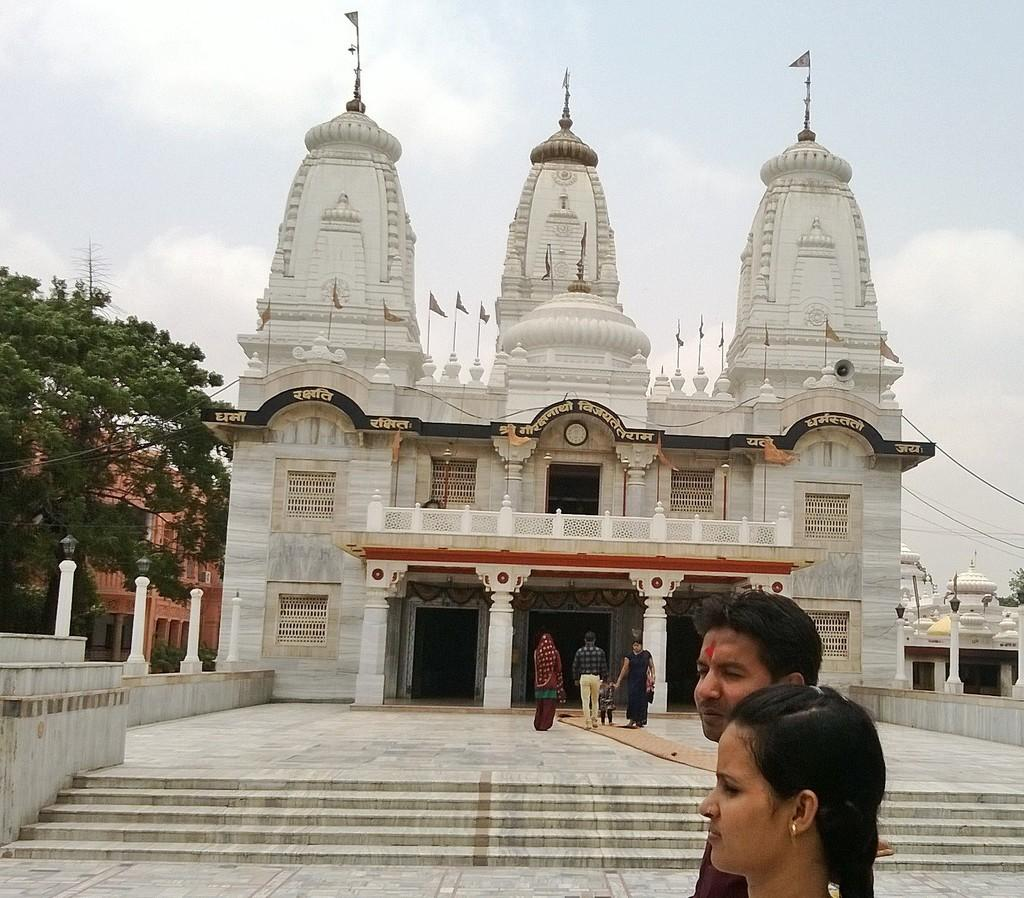What type of structure is the main subject of the image? There is a temple in the image. What other structures can be seen in the image? There are buildings in the image. Are there any architectural features visible in the image? Yes, there are steps in the image. What is the position of the people in the image? People are standing on the ground in the image. What type of vegetation is present in the image? There are trees in the image. What decorations can be seen on the temple? There are flags on the temple in the image. What else is present in the image besides the temple and people? There are wires in the image. What can be seen in the background of the image? The sky is visible in the background of the image. Where is the band performing on the stage in the image? There is no band or stage present in the image; it features a temple, buildings, steps, people, trees, flags, and wires. 